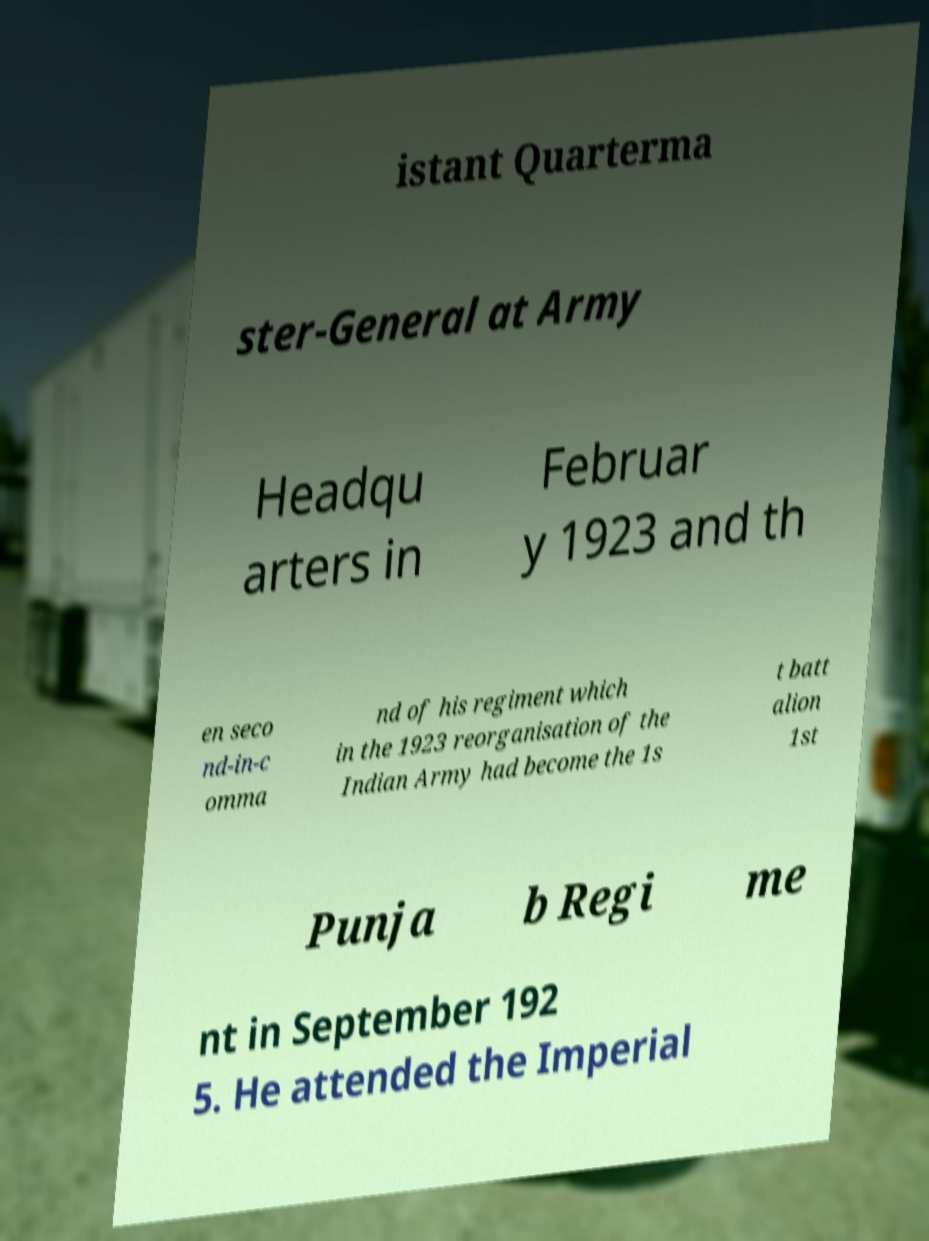Could you extract and type out the text from this image? istant Quarterma ster-General at Army Headqu arters in Februar y 1923 and th en seco nd-in-c omma nd of his regiment which in the 1923 reorganisation of the Indian Army had become the 1s t batt alion 1st Punja b Regi me nt in September 192 5. He attended the Imperial 